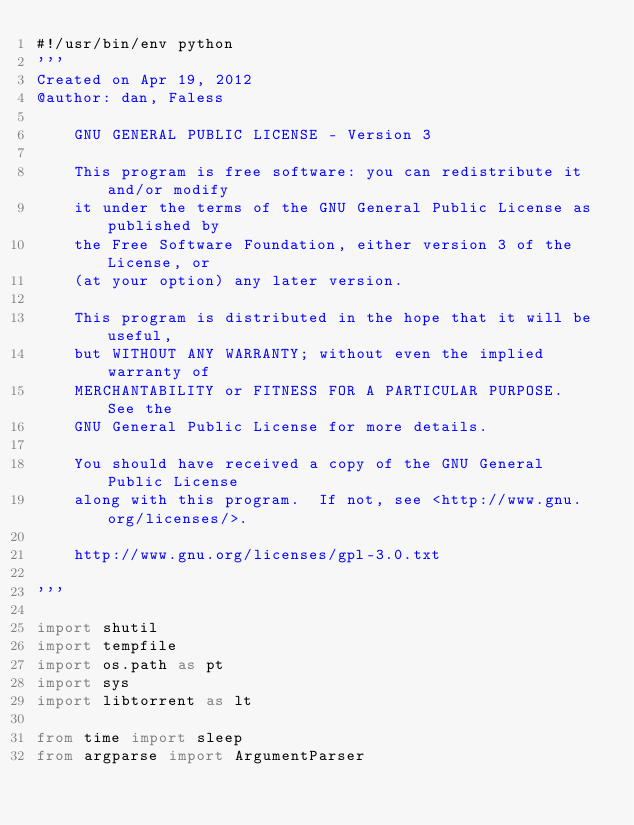<code> <loc_0><loc_0><loc_500><loc_500><_Python_>#!/usr/bin/env python
'''
Created on Apr 19, 2012
@author: dan, Faless

    GNU GENERAL PUBLIC LICENSE - Version 3

    This program is free software: you can redistribute it and/or modify
    it under the terms of the GNU General Public License as published by
    the Free Software Foundation, either version 3 of the License, or
    (at your option) any later version.

    This program is distributed in the hope that it will be useful,
    but WITHOUT ANY WARRANTY; without even the implied warranty of
    MERCHANTABILITY or FITNESS FOR A PARTICULAR PURPOSE.  See the
    GNU General Public License for more details.

    You should have received a copy of the GNU General Public License
    along with this program.  If not, see <http://www.gnu.org/licenses/>.

    http://www.gnu.org/licenses/gpl-3.0.txt

'''

import shutil
import tempfile
import os.path as pt
import sys
import libtorrent as lt

from time import sleep
from argparse import ArgumentParser

</code> 